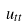Convert formula to latex. <formula><loc_0><loc_0><loc_500><loc_500>u _ { t t }</formula> 